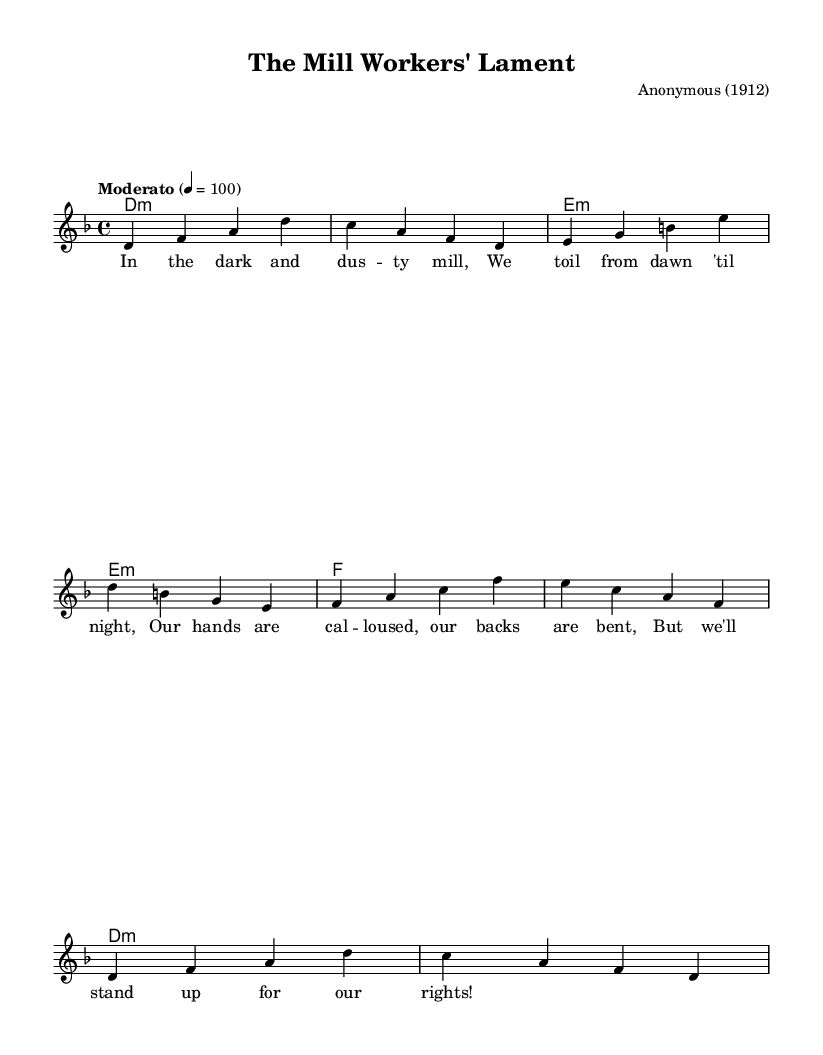What is the key signature of this music? The key signature is indicated with flat or sharp symbols at the beginning of the staff. In this case, it shows that there are no sharps or flats, meaning the piece is in D minor.
Answer: D minor What is the time signature of this music? The time signature is found at the beginning of the piece, denoting how many beats are in each measure. Here, it shows 4 over 4, which means there are four beats per measure.
Answer: 4/4 What is the indicated tempo marking for this music? The tempo marking is usually written above the first measure. In this piece, the term "Moderato" is provided along with a tempo of quarter note equals 100, indicating the speed of the music.
Answer: Moderato 4 = 100 How many measures are in the melody section? By counting the number of segments separated by vertical lines in the melody part, we find there are eight distinct measures in the melody section.
Answer: 8 What is the first lyric of the song? The lyrics are aligned with the notes in the melody section, and the first line of lyrics states, "In the dark and dus -- ty mill," which begins the song's theme.
Answer: In the dark and dus -- ty mill What type of song is "The Mill Workers' Lament"? Based on the title and the lyrics, this piece is categorized as a labor union protest song, which addresses the conditions and rights of workers during the early 20th century.
Answer: Labor union protest song 